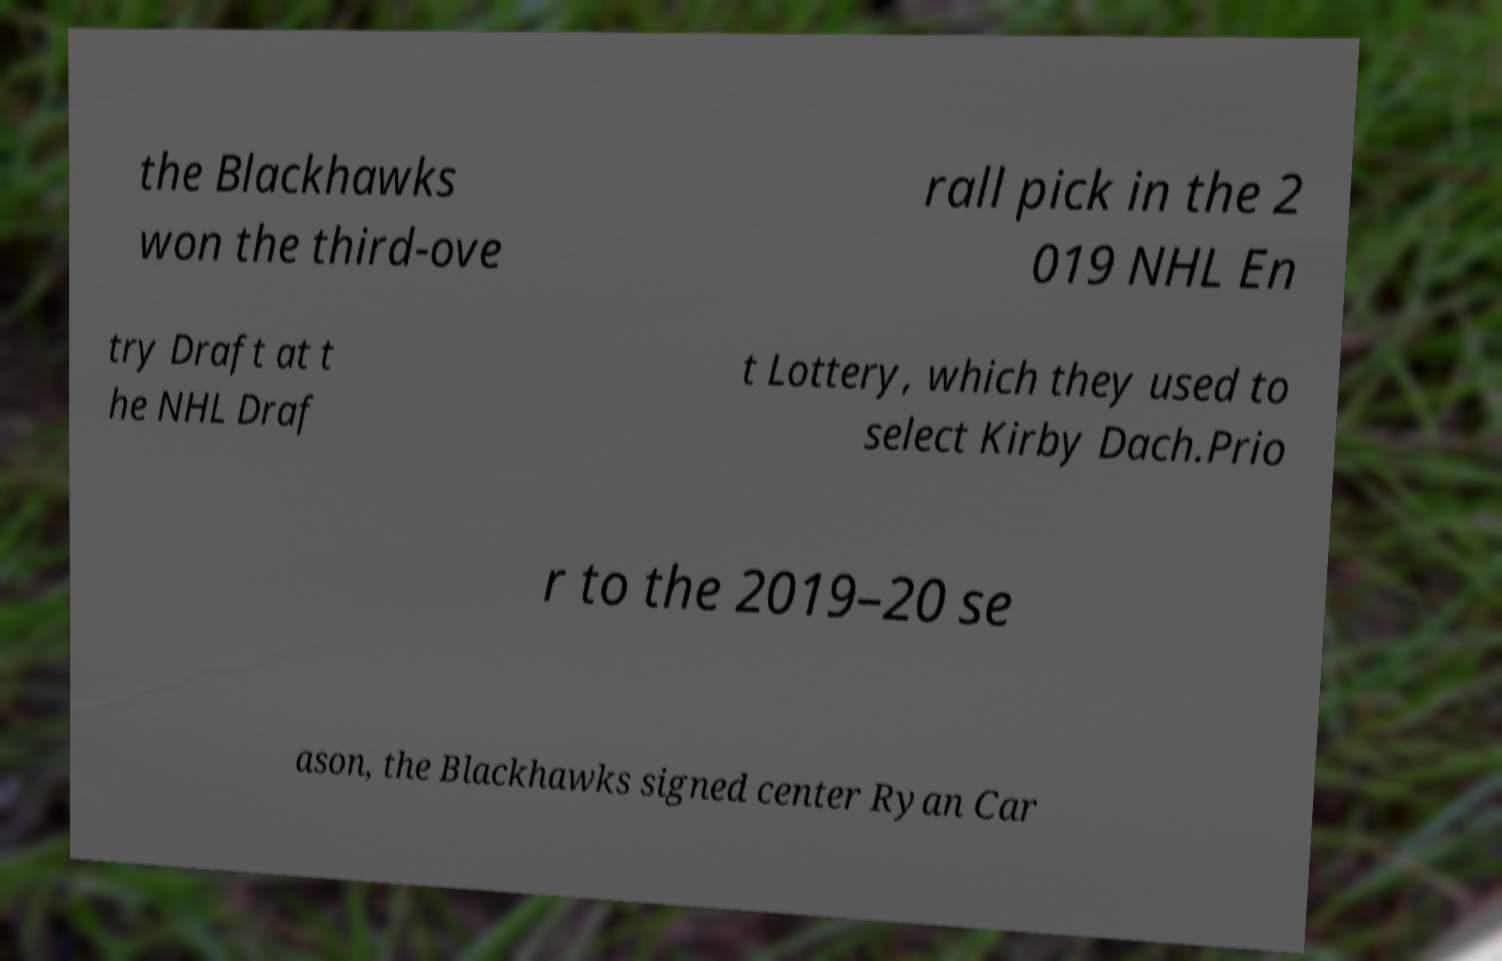For documentation purposes, I need the text within this image transcribed. Could you provide that? the Blackhawks won the third-ove rall pick in the 2 019 NHL En try Draft at t he NHL Draf t Lottery, which they used to select Kirby Dach.Prio r to the 2019–20 se ason, the Blackhawks signed center Ryan Car 